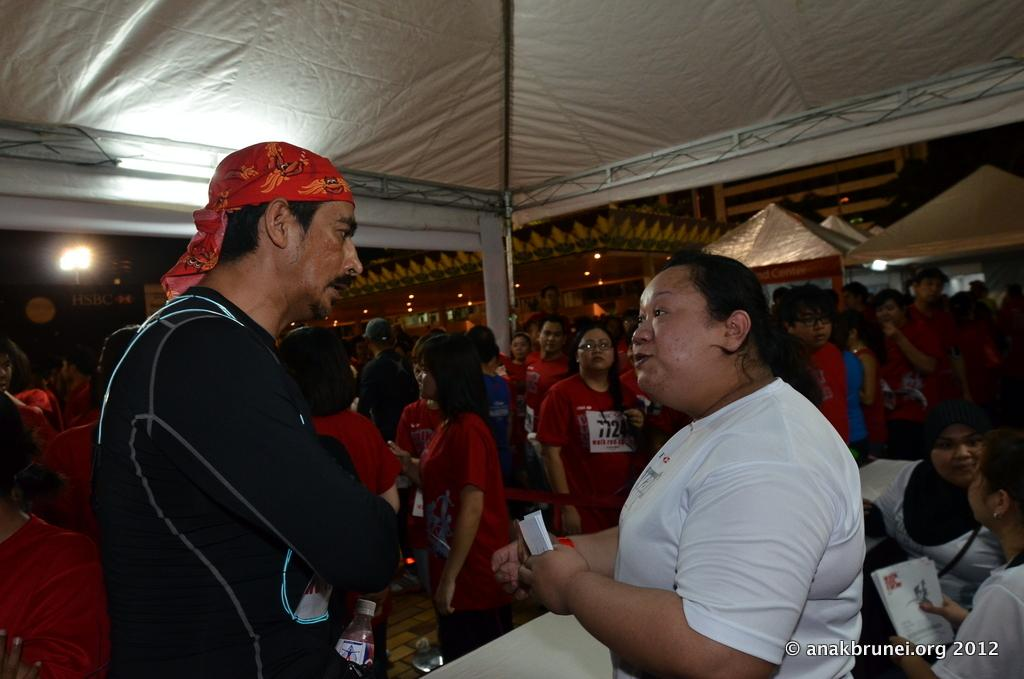How many people are in the image? There are people in the image, but the exact number is not specified. What are two people doing in the image? Two people are holding papers in the image. What object can be seen in the image that is typically used for holding liquids? There is a bottle in the image. What type of shelter is visible in the image? There is a tent in the image. What type of structures can be seen in the background of the image? There are houses in the image. What type of illumination is present in the image? There are lights in the image. What type of object in the image contains written information? There is a board with text in the image. What type of recess can be seen in the image? There is no recess present in the image. What type of arithmetic problem is being solved by the people in the image? There is no indication of any arithmetic problem being solved in the image. 